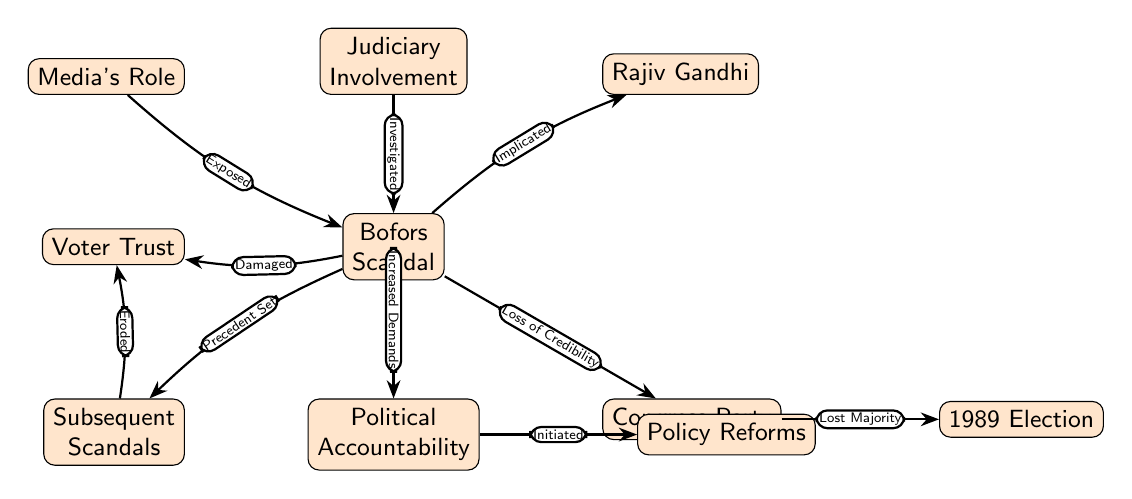What scandal is depicted at the starting point of the diagram? The diagram begins with the Bofors Scandal as the central event that influences various outcomes in the political landscape, indicating its significance in shaping further events and reactions.
Answer: Bofors Scandal Which political figure is implicated in the Bofors Scandal? The diagram directly connects the Bofors Scandal to Rajiv Gandhi, showing that he is associated and implicated with this case.
Answer: Rajiv Gandhi How did the Bofors Scandal impact the Congress Party in the diagram? The relationship shown between the Bofors Scandal and the Congress Party indicates a loss of credibility for the party, leading to negative political consequences for them.
Answer: Loss of Credibility What effect did the Congress Party's downfall have on the 1989 Election? The diagram illustrates that the loss of credibility resulting from the Bofors Scandal caused the Congress Party to lose its majority in the 1989 Election, establishing a direct link between the scandal and the election outcome.
Answer: Lost Majority How did the Bofors Scandal lead to demands for Political Accountability? The diagram indicates that the Bofors Scandal increased public demands for political accountability, creating pressure for changes in political practices and governance.
Answer: Increased Demands What did the Political Accountability lead to in the diagram? The diagram shows the flow from Political Accountability to Policy Reforms, indicating that increased accountability demands initiated reforms in policies to address corruption and governance issues.
Answer: Initiated What impact did Subsequent Scandals have on Voter Trust according to the diagram? The diagram details that Subsequent Scandals eroded Voter Trust, suggesting a cumulative negative effect on public confidence in politicians and the political system following the Bofors Scandal.
Answer: Eroded What role did the media play in the Bofors Scandal? The diagram shows that the media's role was pivotal as it exposed the Bofors Scandal, contributing to the public's awareness and response to the event.
Answer: Exposed How is the judiciary involved in the Bofors Scandal as portrayed in the diagram? The diagram reflects that the judiciary was involved in the case through investigations, highlighting its role in addressing the scandal and ensuring accountability.
Answer: Investigated What type of relationship is shown between the Bofors Scandal and Subsequent Scandals? The diagram outlines a precedent set by the Bofors Scandal which influenced Subsequent Scandals, demonstrating that this event had long-lasting implications for future corruption cases.
Answer: Precedent Set 